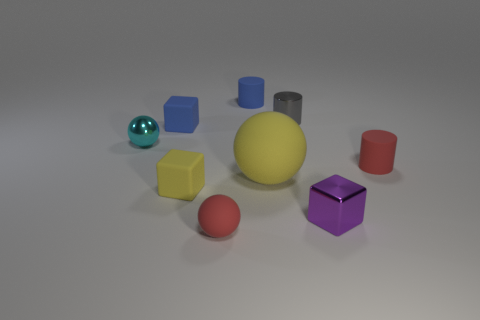What is the color of the tiny matte thing that is in front of the small yellow block?
Offer a very short reply. Red. Are there the same number of red matte cylinders that are left of the purple shiny object and matte balls?
Your response must be concise. No. What is the shape of the rubber thing that is to the right of the blue matte cylinder and in front of the red cylinder?
Make the answer very short. Sphere. There is a big thing that is the same shape as the small cyan thing; what is its color?
Ensure brevity in your answer.  Yellow. Are there any other things that are the same color as the big thing?
Make the answer very short. Yes. What is the shape of the shiny thing behind the sphere on the left side of the tiny rubber block in front of the blue rubber cube?
Keep it short and to the point. Cylinder. Do the shiny thing that is in front of the shiny sphere and the rubber thing that is behind the small blue block have the same size?
Ensure brevity in your answer.  Yes. How many blocks have the same material as the blue cylinder?
Provide a succinct answer. 2. How many metal blocks are left of the matte block that is in front of the tiny red matte object that is behind the red sphere?
Offer a very short reply. 0. Is the shape of the small purple thing the same as the tiny yellow rubber thing?
Provide a succinct answer. Yes. 